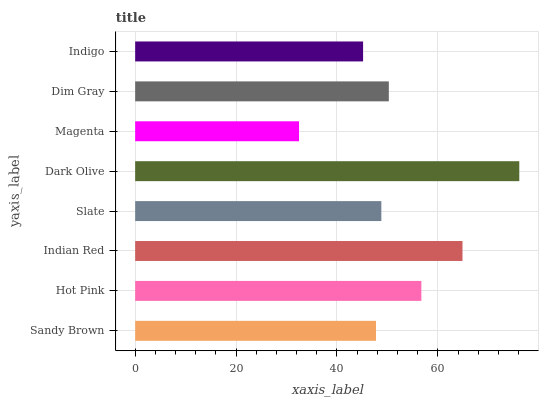Is Magenta the minimum?
Answer yes or no. Yes. Is Dark Olive the maximum?
Answer yes or no. Yes. Is Hot Pink the minimum?
Answer yes or no. No. Is Hot Pink the maximum?
Answer yes or no. No. Is Hot Pink greater than Sandy Brown?
Answer yes or no. Yes. Is Sandy Brown less than Hot Pink?
Answer yes or no. Yes. Is Sandy Brown greater than Hot Pink?
Answer yes or no. No. Is Hot Pink less than Sandy Brown?
Answer yes or no. No. Is Dim Gray the high median?
Answer yes or no. Yes. Is Slate the low median?
Answer yes or no. Yes. Is Indian Red the high median?
Answer yes or no. No. Is Magenta the low median?
Answer yes or no. No. 